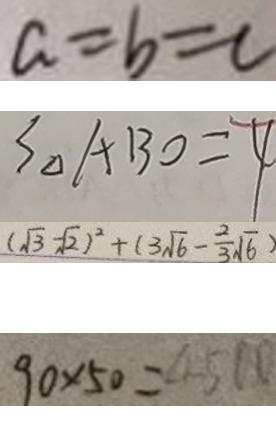<formula> <loc_0><loc_0><loc_500><loc_500>a = b = c 
 S _ { \Delta } A B O = 4 
 ( \sqrt { 3 } - \sqrt { 2 } ) ^ { 2 } + ( 3 \sqrt { 6 } - \frac { 2 } { 3 } \sqrt { 6 } ) 
 9 0 \times 5 0 = 4 5 0 0</formula> 